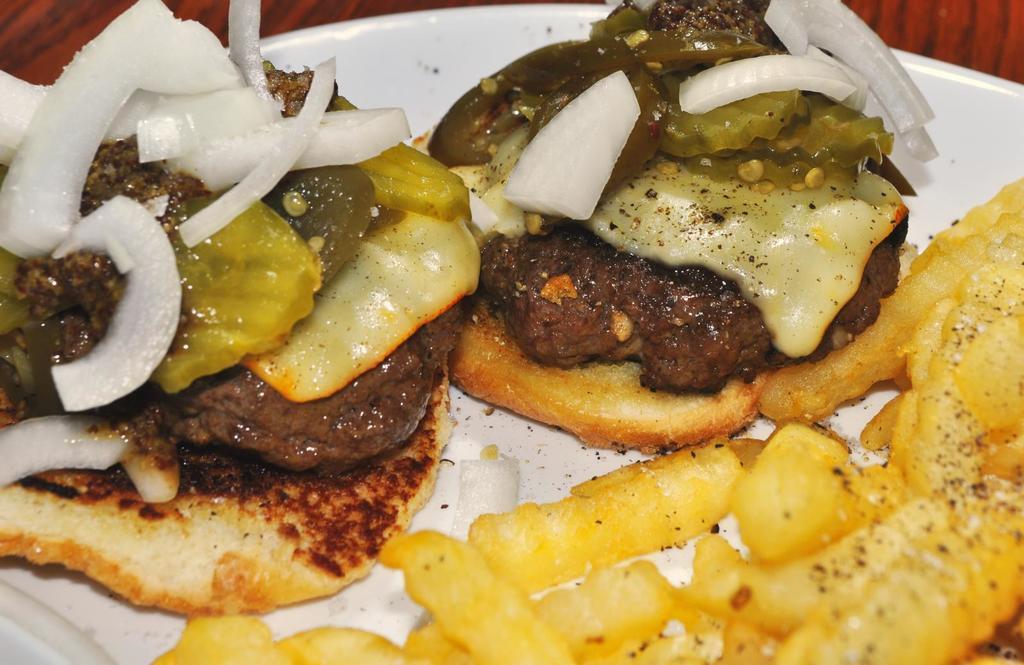Describe this image in one or two sentences. Here in this picture we can see some food in the white plate. 